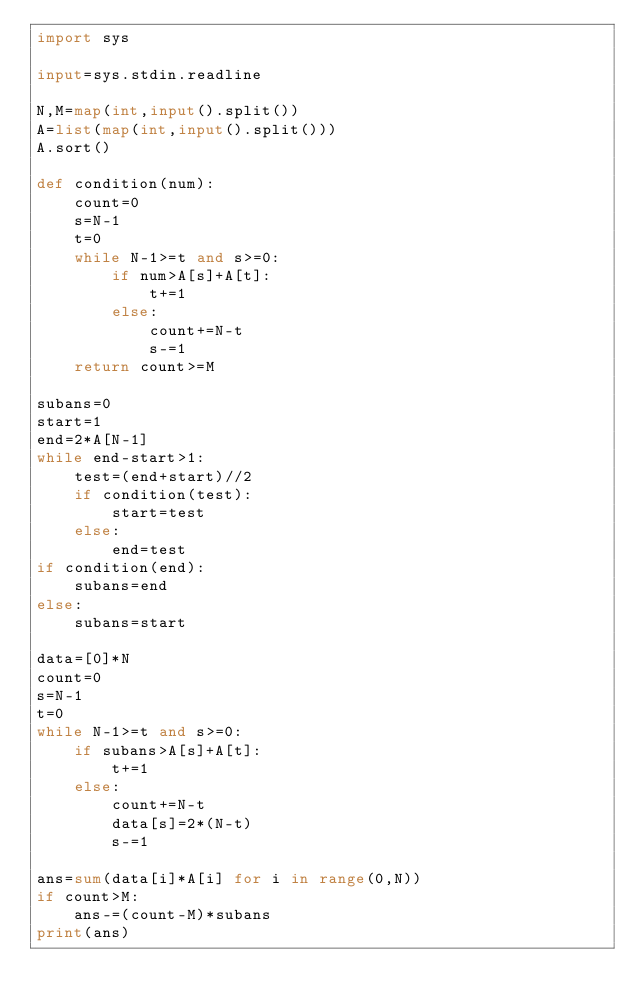<code> <loc_0><loc_0><loc_500><loc_500><_Python_>import sys

input=sys.stdin.readline

N,M=map(int,input().split())
A=list(map(int,input().split()))
A.sort()

def condition(num):
    count=0
    s=N-1
    t=0
    while N-1>=t and s>=0:
        if num>A[s]+A[t]:
            t+=1
        else:
            count+=N-t
            s-=1
    return count>=M

subans=0
start=1
end=2*A[N-1]
while end-start>1:
    test=(end+start)//2
    if condition(test):
        start=test
    else:
        end=test
if condition(end):
    subans=end
else:
    subans=start

data=[0]*N
count=0
s=N-1
t=0
while N-1>=t and s>=0:
    if subans>A[s]+A[t]:
        t+=1
    else:
        count+=N-t
        data[s]=2*(N-t)
        s-=1

ans=sum(data[i]*A[i] for i in range(0,N))
if count>M:
    ans-=(count-M)*subans
print(ans)</code> 